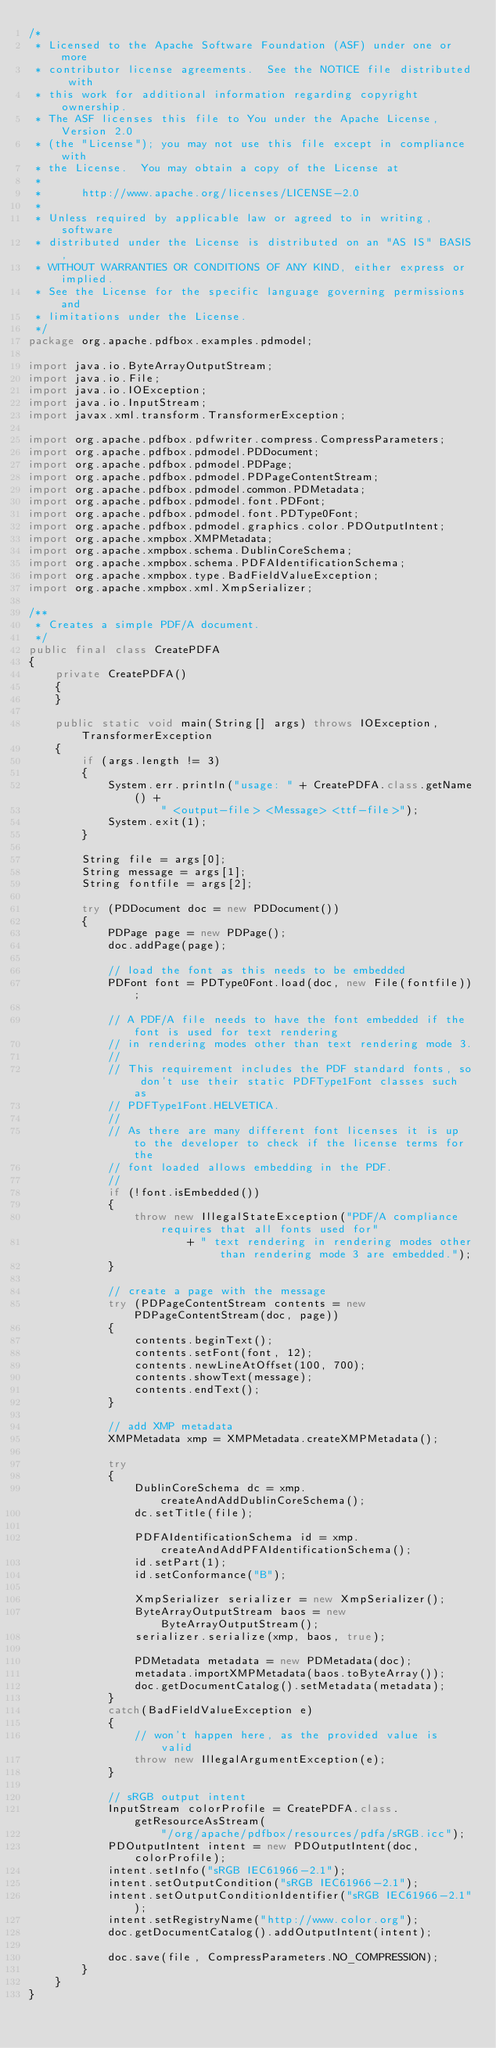Convert code to text. <code><loc_0><loc_0><loc_500><loc_500><_Java_>/*
 * Licensed to the Apache Software Foundation (ASF) under one or more
 * contributor license agreements.  See the NOTICE file distributed with
 * this work for additional information regarding copyright ownership.
 * The ASF licenses this file to You under the Apache License, Version 2.0
 * (the "License"); you may not use this file except in compliance with
 * the License.  You may obtain a copy of the License at
 *
 *      http://www.apache.org/licenses/LICENSE-2.0
 *
 * Unless required by applicable law or agreed to in writing, software
 * distributed under the License is distributed on an "AS IS" BASIS,
 * WITHOUT WARRANTIES OR CONDITIONS OF ANY KIND, either express or implied.
 * See the License for the specific language governing permissions and
 * limitations under the License.
 */
package org.apache.pdfbox.examples.pdmodel;

import java.io.ByteArrayOutputStream;
import java.io.File;
import java.io.IOException;
import java.io.InputStream;
import javax.xml.transform.TransformerException;

import org.apache.pdfbox.pdfwriter.compress.CompressParameters;
import org.apache.pdfbox.pdmodel.PDDocument;
import org.apache.pdfbox.pdmodel.PDPage;
import org.apache.pdfbox.pdmodel.PDPageContentStream;
import org.apache.pdfbox.pdmodel.common.PDMetadata;
import org.apache.pdfbox.pdmodel.font.PDFont;
import org.apache.pdfbox.pdmodel.font.PDType0Font;
import org.apache.pdfbox.pdmodel.graphics.color.PDOutputIntent;
import org.apache.xmpbox.XMPMetadata;
import org.apache.xmpbox.schema.DublinCoreSchema;
import org.apache.xmpbox.schema.PDFAIdentificationSchema;
import org.apache.xmpbox.type.BadFieldValueException;
import org.apache.xmpbox.xml.XmpSerializer;

/**
 * Creates a simple PDF/A document.
 */
public final class CreatePDFA
{
    private CreatePDFA()
    {
    }
    
    public static void main(String[] args) throws IOException, TransformerException
    {
        if (args.length != 3)
        {
            System.err.println("usage: " + CreatePDFA.class.getName() +
                    " <output-file> <Message> <ttf-file>");
            System.exit(1);
        }

        String file = args[0];
        String message = args[1];
        String fontfile = args[2];

        try (PDDocument doc = new PDDocument())
        {
            PDPage page = new PDPage();
            doc.addPage(page);

            // load the font as this needs to be embedded
            PDFont font = PDType0Font.load(doc, new File(fontfile));

            // A PDF/A file needs to have the font embedded if the font is used for text rendering
            // in rendering modes other than text rendering mode 3.
            //
            // This requirement includes the PDF standard fonts, so don't use their static PDFType1Font classes such as
            // PDFType1Font.HELVETICA.
            //
            // As there are many different font licenses it is up to the developer to check if the license terms for the
            // font loaded allows embedding in the PDF.
            // 
            if (!font.isEmbedded())
            {
            	throw new IllegalStateException("PDF/A compliance requires that all fonts used for"
            			+ " text rendering in rendering modes other than rendering mode 3 are embedded.");
            }
            
            // create a page with the message
            try (PDPageContentStream contents = new PDPageContentStream(doc, page))
            {
                contents.beginText();
                contents.setFont(font, 12);
                contents.newLineAtOffset(100, 700);
                contents.showText(message);
                contents.endText();
            }

            // add XMP metadata
            XMPMetadata xmp = XMPMetadata.createXMPMetadata();
            
            try
            {
                DublinCoreSchema dc = xmp.createAndAddDublinCoreSchema();
                dc.setTitle(file);
                
                PDFAIdentificationSchema id = xmp.createAndAddPFAIdentificationSchema();
                id.setPart(1);
                id.setConformance("B");
                
                XmpSerializer serializer = new XmpSerializer();
                ByteArrayOutputStream baos = new ByteArrayOutputStream();
                serializer.serialize(xmp, baos, true);

                PDMetadata metadata = new PDMetadata(doc);
                metadata.importXMPMetadata(baos.toByteArray());
                doc.getDocumentCatalog().setMetadata(metadata);
            }
            catch(BadFieldValueException e)
            {
                // won't happen here, as the provided value is valid
                throw new IllegalArgumentException(e);
            }

            // sRGB output intent
            InputStream colorProfile = CreatePDFA.class.getResourceAsStream(
                    "/org/apache/pdfbox/resources/pdfa/sRGB.icc");
            PDOutputIntent intent = new PDOutputIntent(doc, colorProfile);
            intent.setInfo("sRGB IEC61966-2.1");
            intent.setOutputCondition("sRGB IEC61966-2.1");
            intent.setOutputConditionIdentifier("sRGB IEC61966-2.1");
            intent.setRegistryName("http://www.color.org");
            doc.getDocumentCatalog().addOutputIntent(intent);

            doc.save(file, CompressParameters.NO_COMPRESSION);
        }
    }
}
</code> 